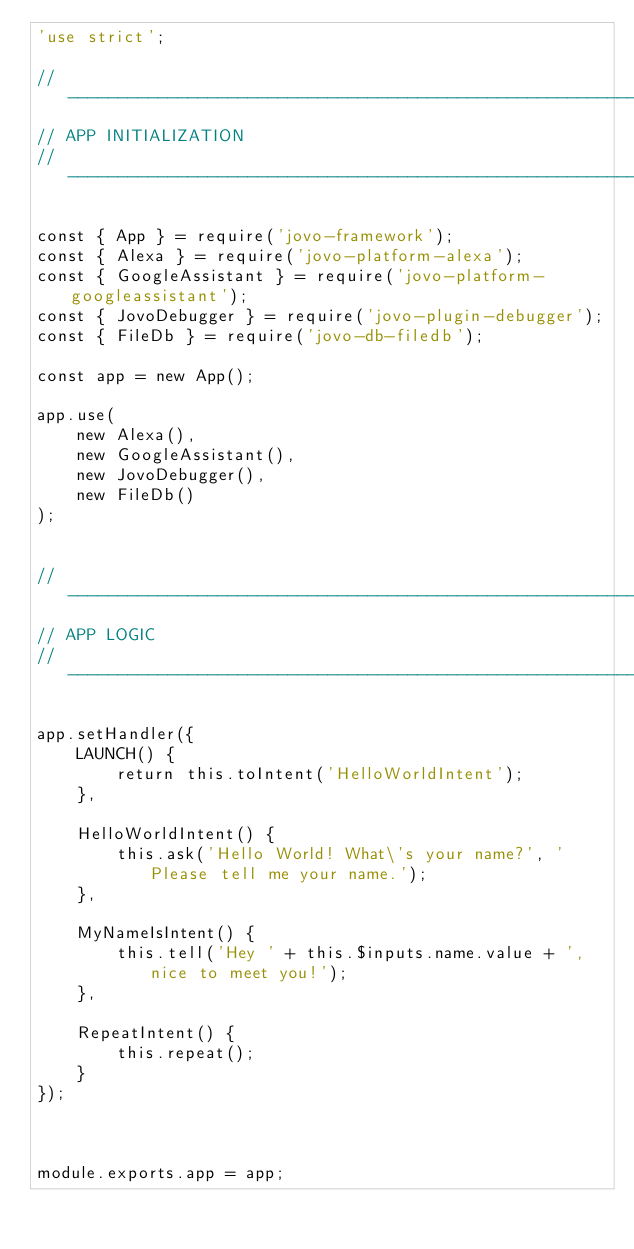Convert code to text. <code><loc_0><loc_0><loc_500><loc_500><_JavaScript_>'use strict';

// ------------------------------------------------------------------
// APP INITIALIZATION
// ------------------------------------------------------------------

const { App } = require('jovo-framework');
const { Alexa } = require('jovo-platform-alexa');
const { GoogleAssistant } = require('jovo-platform-googleassistant');
const { JovoDebugger } = require('jovo-plugin-debugger');
const { FileDb } = require('jovo-db-filedb');

const app = new App();

app.use(
    new Alexa(),
    new GoogleAssistant(),
    new JovoDebugger(),
    new FileDb()
);


// ------------------------------------------------------------------
// APP LOGIC
// ------------------------------------------------------------------

app.setHandler({
    LAUNCH() {
        return this.toIntent('HelloWorldIntent');
    },

    HelloWorldIntent() {
        this.ask('Hello World! What\'s your name?', 'Please tell me your name.');
    },

    MyNameIsIntent() {
        this.tell('Hey ' + this.$inputs.name.value + ', nice to meet you!');
    },
    
    RepeatIntent() {
        this.repeat();
    }
});



module.exports.app = app;
</code> 